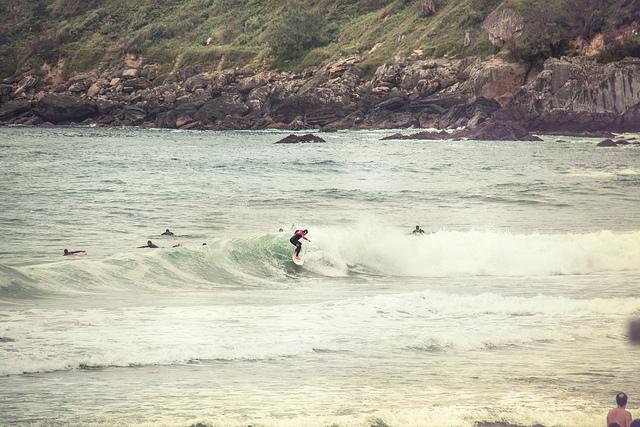What other activity can be carried out here besides surfing?

Choices:
A) paddling
B) rafting
C) canoeing
D) swimming swimming 